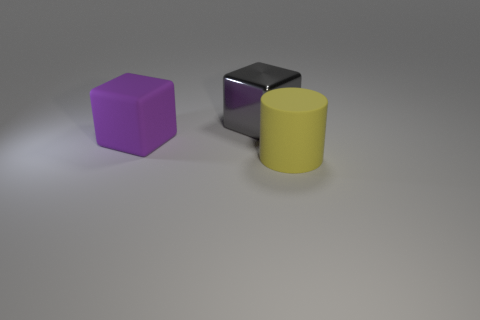Add 2 gray cubes. How many objects exist? 5 Subtract all cylinders. How many objects are left? 2 Add 2 large matte objects. How many large matte objects are left? 4 Add 3 large yellow objects. How many large yellow objects exist? 4 Subtract 1 yellow cylinders. How many objects are left? 2 Subtract all gray shiny blocks. Subtract all large gray metallic things. How many objects are left? 1 